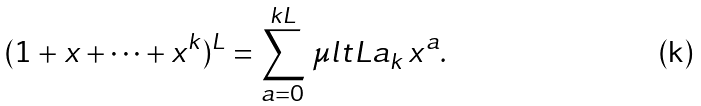Convert formula to latex. <formula><loc_0><loc_0><loc_500><loc_500>( 1 + x + \cdots + x ^ { k } ) ^ { L } = \sum _ { a = 0 } ^ { k L } \, \mu l t { L } { a } _ { k } \, x ^ { a } .</formula> 